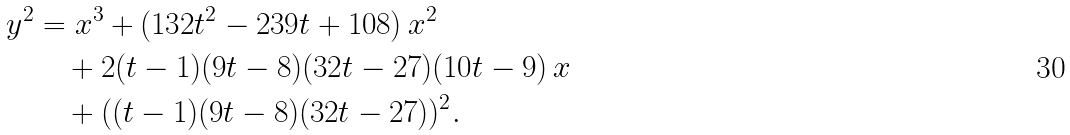<formula> <loc_0><loc_0><loc_500><loc_500>y ^ { 2 } & = x ^ { 3 } + ( 1 3 2 t ^ { 2 } - 2 3 9 t + 1 0 8 ) \, x ^ { 2 } \\ & \quad + 2 ( t - 1 ) ( 9 t - 8 ) ( 3 2 t - 2 7 ) ( 1 0 t - 9 ) \, x \\ & \quad + ( ( t - 1 ) ( 9 t - 8 ) ( 3 2 t - 2 7 ) ) ^ { 2 } .</formula> 